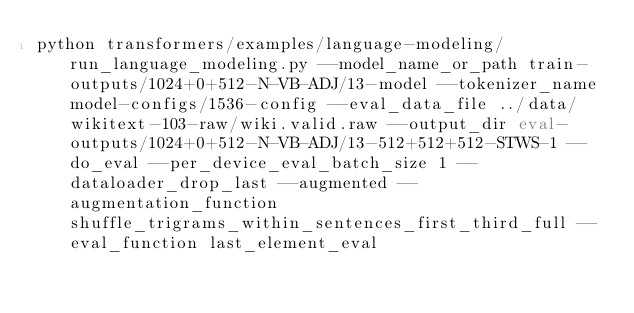<code> <loc_0><loc_0><loc_500><loc_500><_Bash_>python transformers/examples/language-modeling/run_language_modeling.py --model_name_or_path train-outputs/1024+0+512-N-VB-ADJ/13-model --tokenizer_name model-configs/1536-config --eval_data_file ../data/wikitext-103-raw/wiki.valid.raw --output_dir eval-outputs/1024+0+512-N-VB-ADJ/13-512+512+512-STWS-1 --do_eval --per_device_eval_batch_size 1 --dataloader_drop_last --augmented --augmentation_function shuffle_trigrams_within_sentences_first_third_full --eval_function last_element_eval</code> 